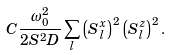Convert formula to latex. <formula><loc_0><loc_0><loc_500><loc_500>C \frac { \omega _ { 0 } ^ { 2 } } { 2 S ^ { 2 } D } \sum _ { l } \left ( S _ { l } ^ { x } \right ) ^ { 2 } \left ( S _ { l } ^ { z } \right ) ^ { 2 } .</formula> 